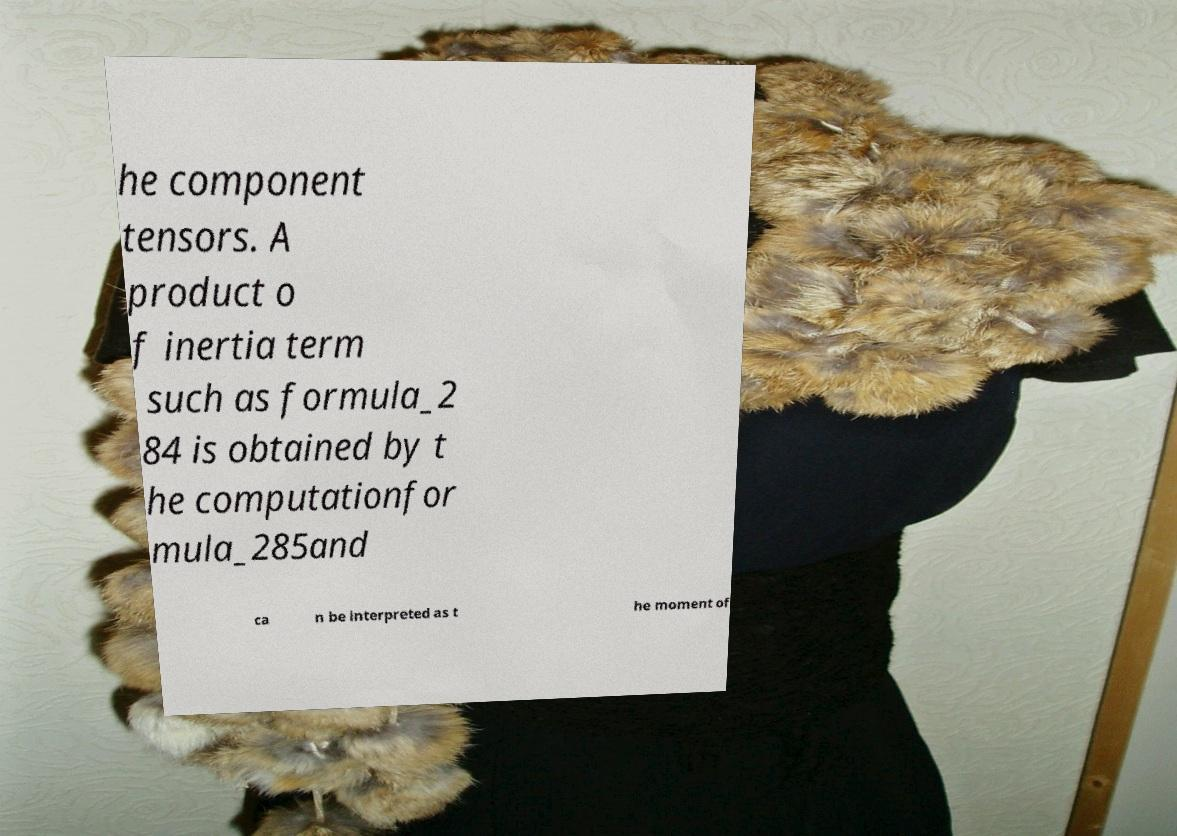Could you assist in decoding the text presented in this image and type it out clearly? he component tensors. A product o f inertia term such as formula_2 84 is obtained by t he computationfor mula_285and ca n be interpreted as t he moment of 